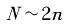Convert formula to latex. <formula><loc_0><loc_0><loc_500><loc_500>N \sim 2 n</formula> 